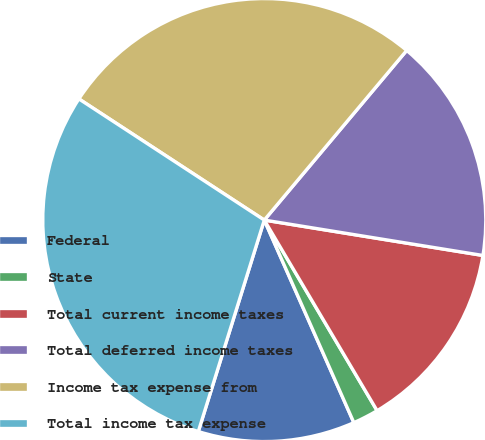<chart> <loc_0><loc_0><loc_500><loc_500><pie_chart><fcel>Federal<fcel>State<fcel>Total current income taxes<fcel>Total deferred income taxes<fcel>Income tax expense from<fcel>Total income tax expense<nl><fcel>11.44%<fcel>1.88%<fcel>13.94%<fcel>16.44%<fcel>26.9%<fcel>29.4%<nl></chart> 